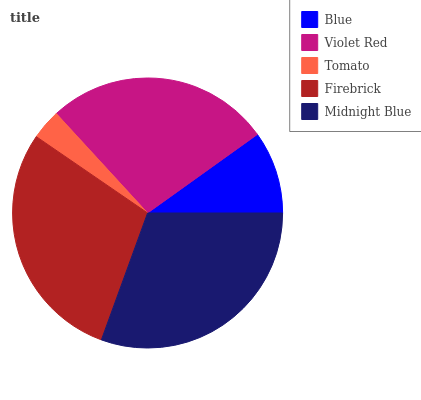Is Tomato the minimum?
Answer yes or no. Yes. Is Midnight Blue the maximum?
Answer yes or no. Yes. Is Violet Red the minimum?
Answer yes or no. No. Is Violet Red the maximum?
Answer yes or no. No. Is Violet Red greater than Blue?
Answer yes or no. Yes. Is Blue less than Violet Red?
Answer yes or no. Yes. Is Blue greater than Violet Red?
Answer yes or no. No. Is Violet Red less than Blue?
Answer yes or no. No. Is Violet Red the high median?
Answer yes or no. Yes. Is Violet Red the low median?
Answer yes or no. Yes. Is Midnight Blue the high median?
Answer yes or no. No. Is Blue the low median?
Answer yes or no. No. 